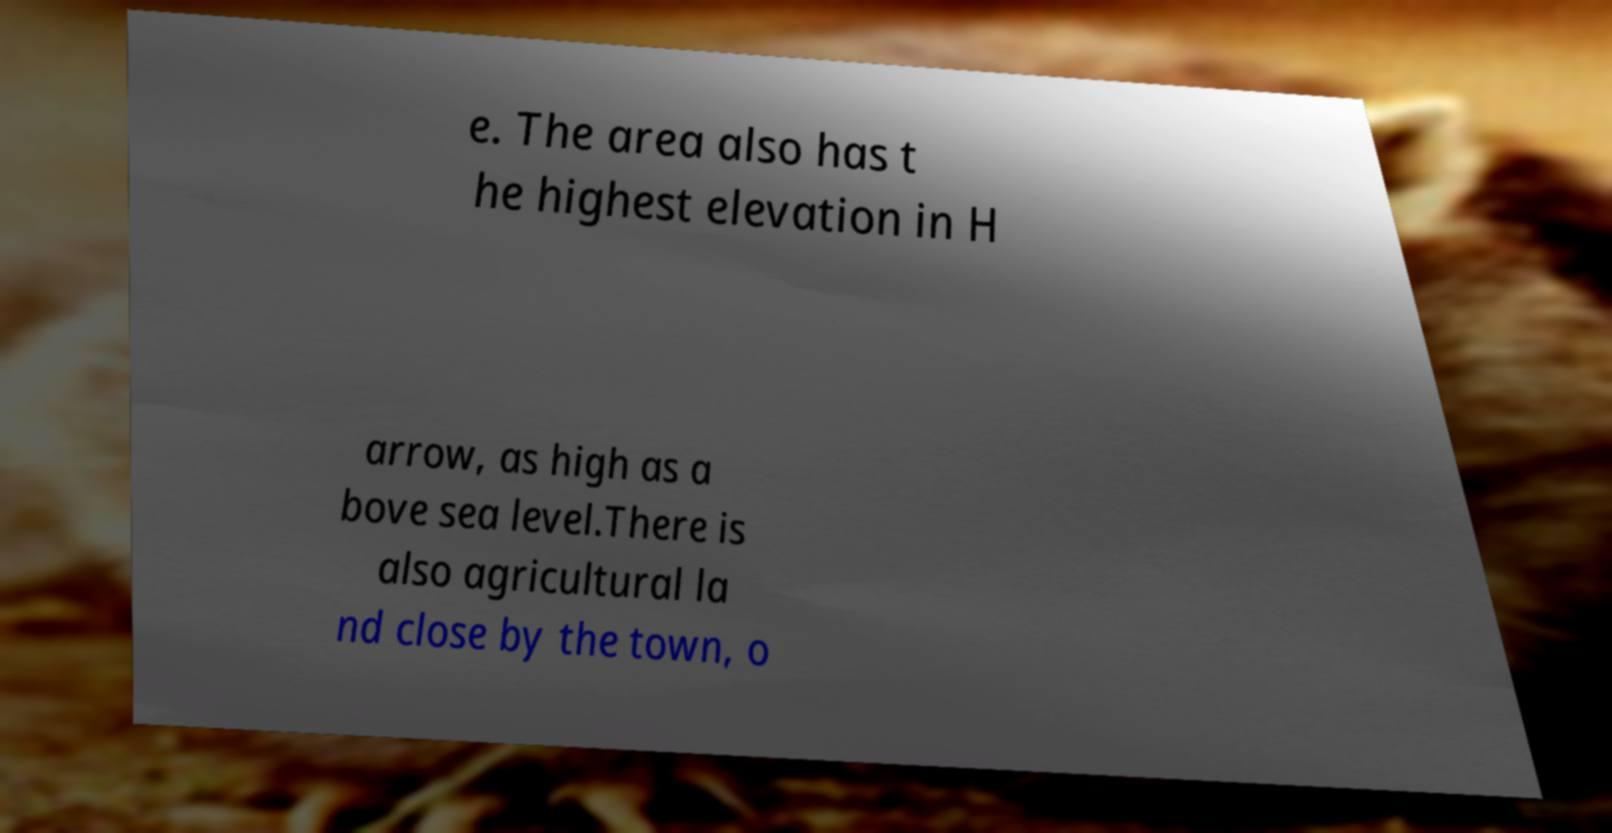Can you accurately transcribe the text from the provided image for me? e. The area also has t he highest elevation in H arrow, as high as a bove sea level.There is also agricultural la nd close by the town, o 